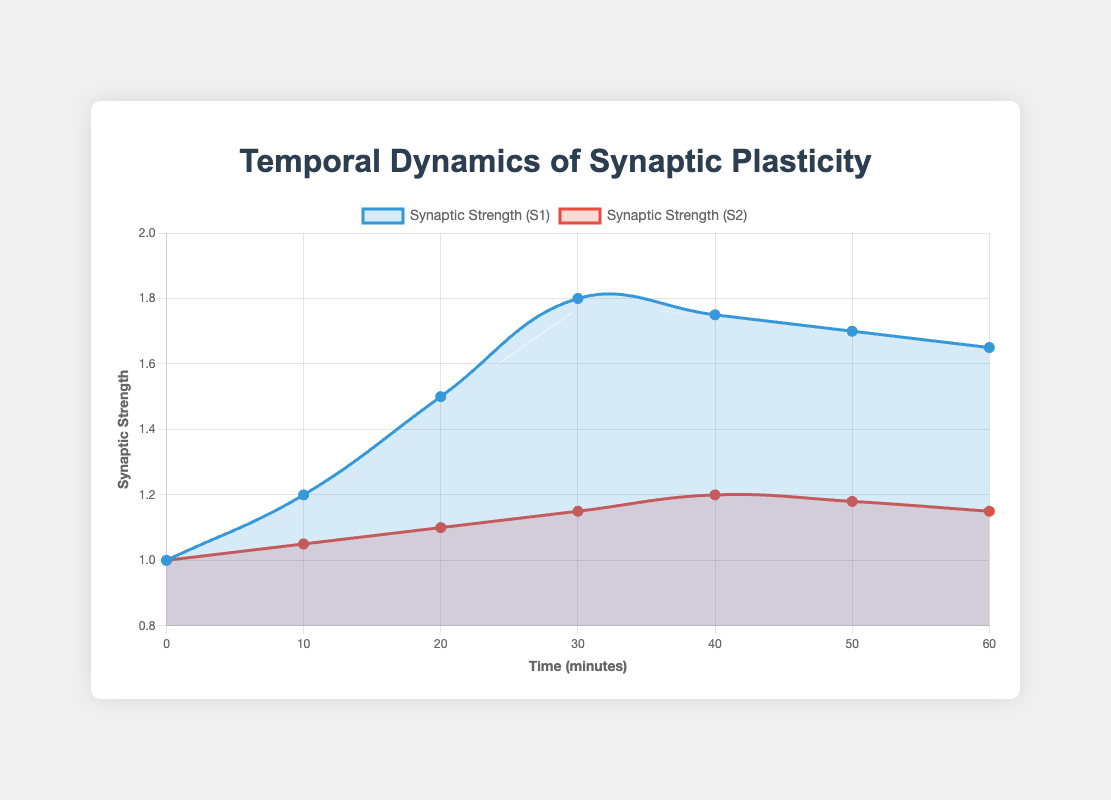What is the trend in Synaptic Strength (S1) over the 60-minute period? To determine the trend, observe the changes in Synaptic Strength (S1) at each time point. Initially, Synaptic Strength (S1) increases consistently from 1.0 to 1.8 in the first 30 minutes, showing a gradual yet steady rise. Afterwards, it slightly decreases over the next 30 minutes to 1.65. Overall, the trend shows an initial increase followed by a slight decrease.
Answer: Initial increase followed by a slight decrease Which time point shows the highest Synaptic Strength (S1)? From the plot, the highest Synaptic Strength (S1) is observed at the 30-minute mark with a value of 1.8.
Answer: 30 minutes Compare the Synaptic Strength (S2) at the 20-minute mark with that at the 40-minute mark. Which one is greater? To compare, look at the Synaptic Strength (S2) values at these time points. At 20 minutes, the value is 1.10, and at 40 minutes, the value is 1.20. The Synaptic Strength (S2) at 40 minutes is greater.
Answer: 1.20 at 40 minutes is greater What is the difference between Synaptic Strength (S1) and Synaptic Strength (S2) at the 10-minute mark? At the 10-minute mark, Synaptic Strength (S1) is 1.2 and Synaptic Strength (S2) is 1.05. The difference is calculated as 1.2 - 1.05 = 0.15.
Answer: 0.15 During which task phases does Synaptic Strength (S2) increase? By examining the plotted data points for Synaptic Strength (S2) along with the task labels, Synaptic Strength (S2) shows an increase during the Initial Learning Phase (10 minutes), Continued Learning Phase (20 minutes), Consolidation Phase (30 minutes), and Memory Retention Phase (40 minutes).
Answer: Initial Learning Phase, Continued Learning Phase, Consolidation Phase, Memory Retention Phase What was the largest increase observed in Synaptic Strength (S2) between two consecutive time points? To find this, calculate the difference in Synaptic Strength (S2) between each pair of consecutive time points: 
- 0 to 10 minutes: 1.05 - 1.00 = 0.05
- 10 to 20 minutes: 1.10 - 1.05 = 0.05
- 20 to 30 minutes: 1.15 - 1.10 = 0.05
- 30 to 40 minutes: 1.20 - 1.15 = 0.05
- 40 to 50 minutes: 1.18 - 1.20 = -0.02 (decrease)
- 50 to 60 minutes: 1.15 - 1.18 = -0.03 (decrease)
The largest increase (+0.05) is constant over several intervals (10 to 20, 20 to 30, and 30 to 40 minutes).
Answer: 0.05 between 10 to 20, 20 to 30, and 30 to 40 minutes Is there any phase where Synaptic Strength (S1) and Synaptic Strength (S2) both decrease? Analyze the values of Synaptic Strength (S1) and Synaptic Strength (S2) for any decrease. Both decrease from:
- 40 to 50 minutes (S1: 1.75 to 1.70 and S2: 1.20 to 1.18)
- 50 to 60 minutes (S1: 1.70 to 1.65 and S2: 1.18 to 1.15)
These decreases correspond to the Post-Task Resting and Long-term Recall phases.
Answer: Post-Task Resting and Long-term Recall What is the compositional difference between the maximum and minimum values of Synaptic Strength (S1)? The maximum value of Synaptic Strength (S1) is 1.8 (at 30 minutes), and the minimum value is 1.0 (at 0 minutes). The difference is calculated as 1.8 - 1.0 = 0.8.
Answer: 0.8 